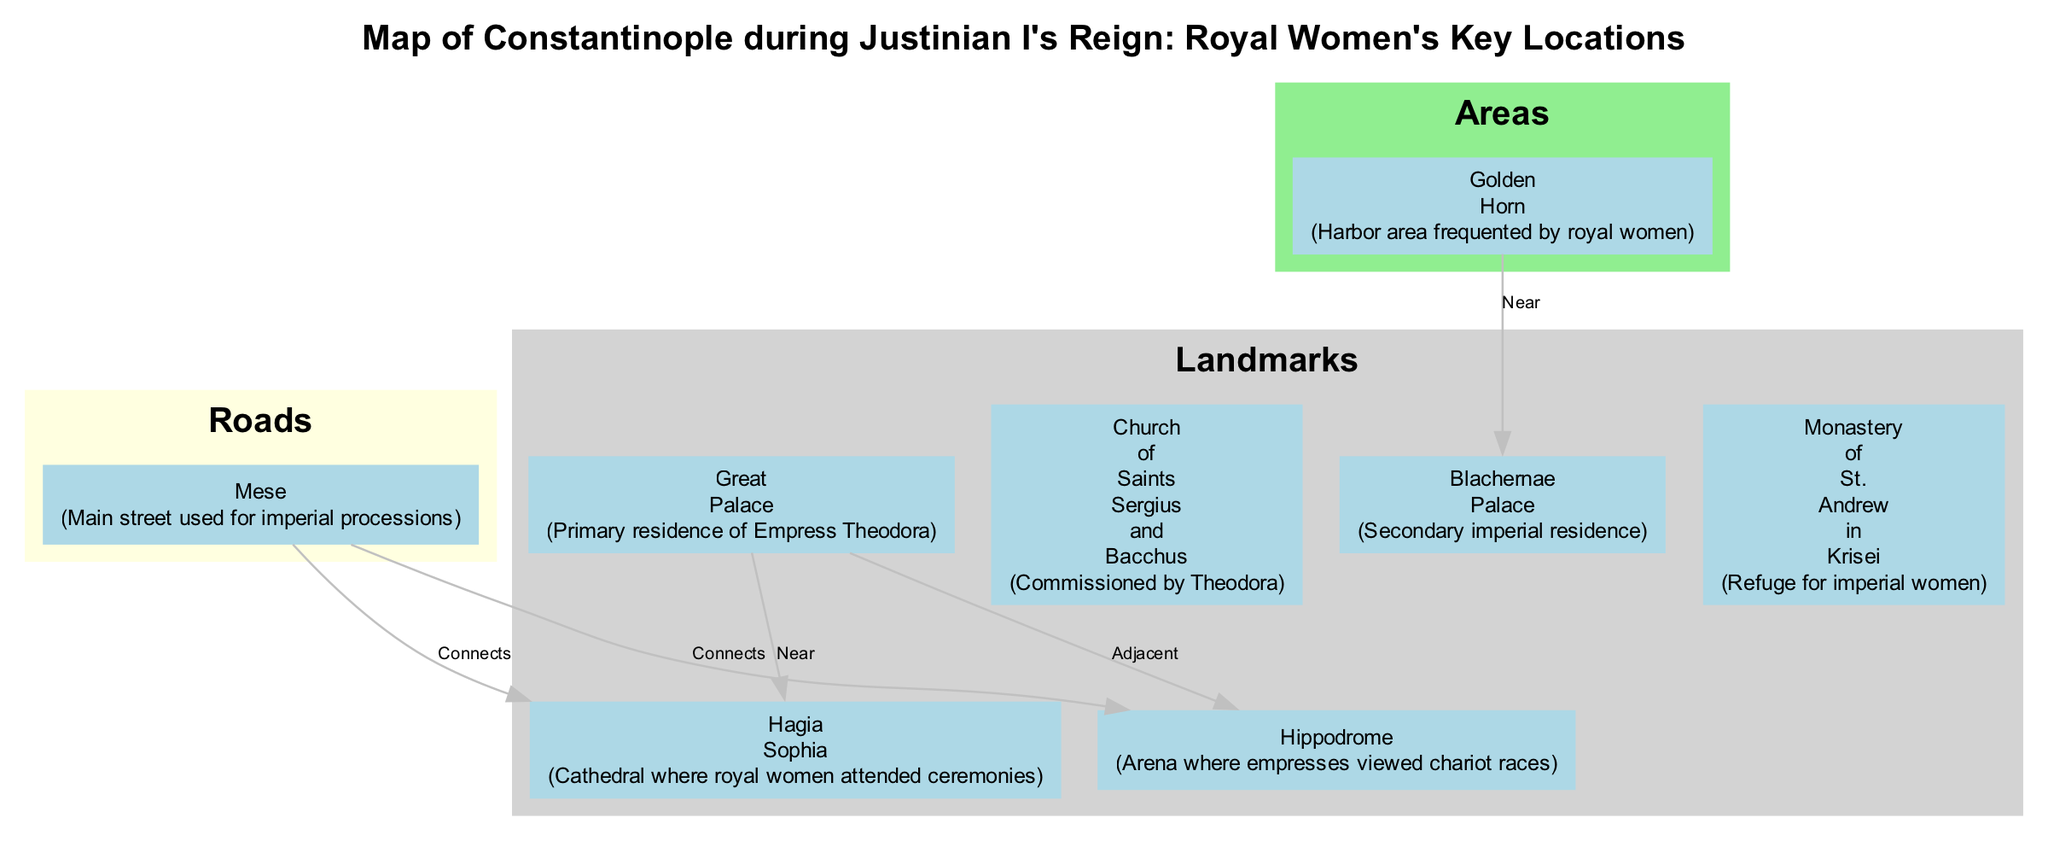What is the primary residence of Empress Theodora? The diagram indicates that the "Great Palace" is labeled as the primary residence of Empress Theodora, which is directly stated in the description of that landmark.
Answer: Great Palace How many landmarks are shown in the diagram? By counting all the entries under the "Landmarks" category in the diagram, one can determine that there are five landmarks listed: Great Palace, Hagia Sophia, Hippodrome, Church of Saints Sergius and Bacchus, and Blachernae Palace.
Answer: 5 Which landmark is a place where royal women attended ceremonies? The description of the "Hagia Sophia" explicitly mentions that it is the cathedral where royal women attended ceremonies, making it the correct answer based on the provided visual information.
Answer: Hagia Sophia What connects the Great Palace to the Hippodrome? The diagram shows an edge labeled "Adjacent" between the "Great Palace" and "Hippodrome," indicating a direct connection that describes their physical proximity in Constantinople.
Answer: Adjacent Which area is frequented by royal women? The "Golden Horn" is described in the diagram as a harbor area that was frequently visited by royal women, which directly answers the question about locations of interest for the royal women.
Answer: Golden Horn Which landmark was commissioned by Theodora? According to the diagram, the "Church of Saints Sergius and Bacchus" is specifically noted as being commissioned by Theodora, which is the basis for answering this question accurately.
Answer: Church of Saints Sergius and Bacchus What is the main street used for imperial processions? The "Mese" is named in the diagram as the main street utilized for imperial processions, making it the answer that describes the major route for these events.
Answer: Mese Which landmark provides refuge for imperial women? The "Monastery of St. Andrew in Krisei" is identified in the diagram as a refuge for imperial women, providing a clear answer to this inquiry about support and safety for royal figures.
Answer: Monastery of St. Andrew in Krisei What is the relationship between the Mese and Hagia Sophia? The diagram indicates an edge labeled "Connects" between the "Mese" and "Hagia Sophia," implying that they are connected through this main street, which reveals their relationship in an infrastructural context.
Answer: Connects 